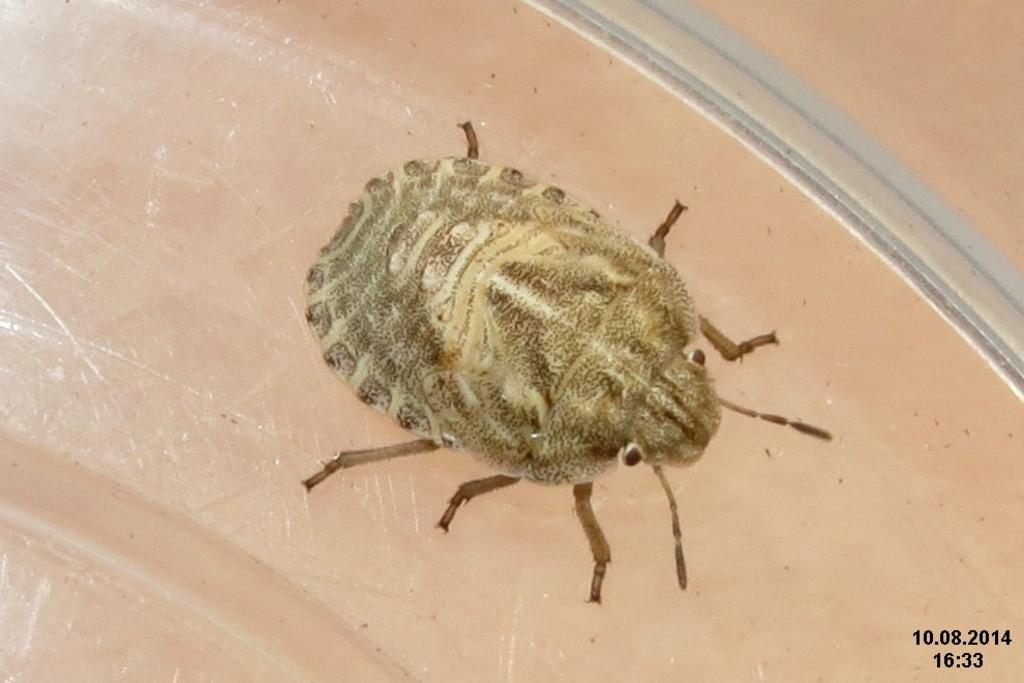What type of creature is in the image? There is an insect in the image. Where is the insect located? The insect is on a table. What country is the insect from in the image? The image does not provide information about the insect's origin or country. How many eyes does the insect have in the image? The image does not provide information about the number of eyes the insect has. 